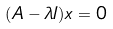Convert formula to latex. <formula><loc_0><loc_0><loc_500><loc_500>( A - \lambda I ) x = 0</formula> 